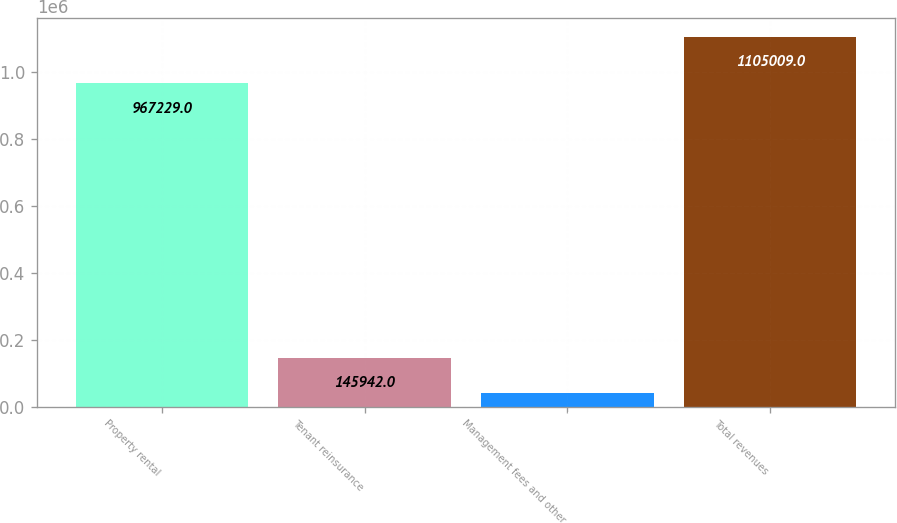Convert chart to OTSL. <chart><loc_0><loc_0><loc_500><loc_500><bar_chart><fcel>Property rental<fcel>Tenant reinsurance<fcel>Management fees and other<fcel>Total revenues<nl><fcel>967229<fcel>145942<fcel>39379<fcel>1.10501e+06<nl></chart> 